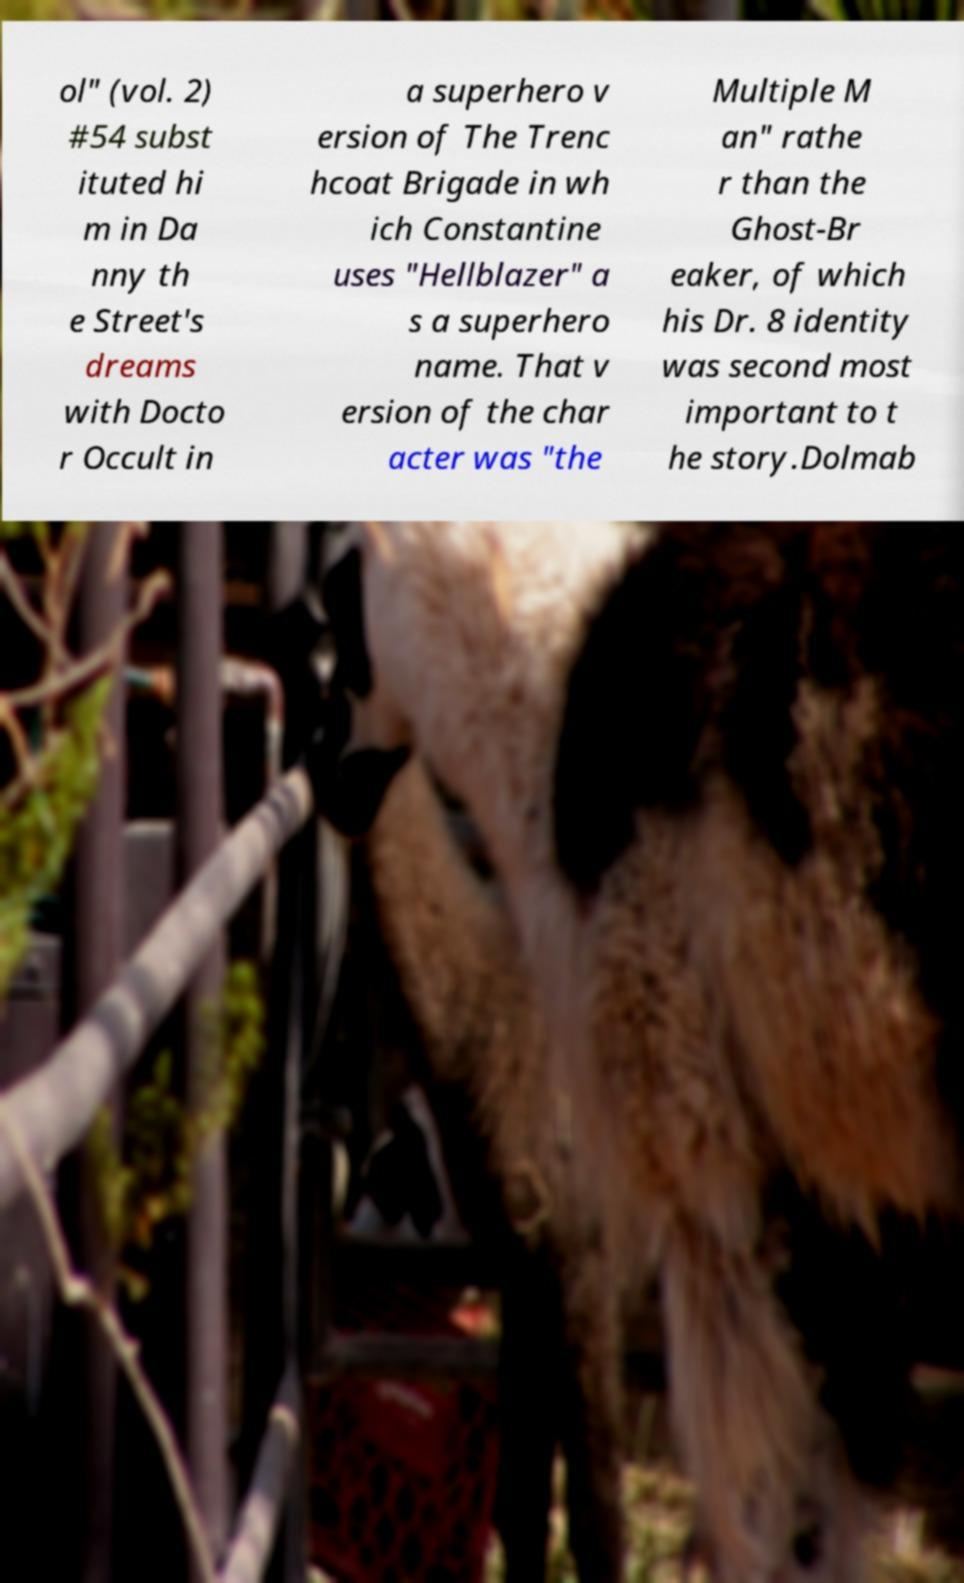Please identify and transcribe the text found in this image. ol" (vol. 2) #54 subst ituted hi m in Da nny th e Street's dreams with Docto r Occult in a superhero v ersion of The Trenc hcoat Brigade in wh ich Constantine uses "Hellblazer" a s a superhero name. That v ersion of the char acter was "the Multiple M an" rathe r than the Ghost-Br eaker, of which his Dr. 8 identity was second most important to t he story.Dolmab 